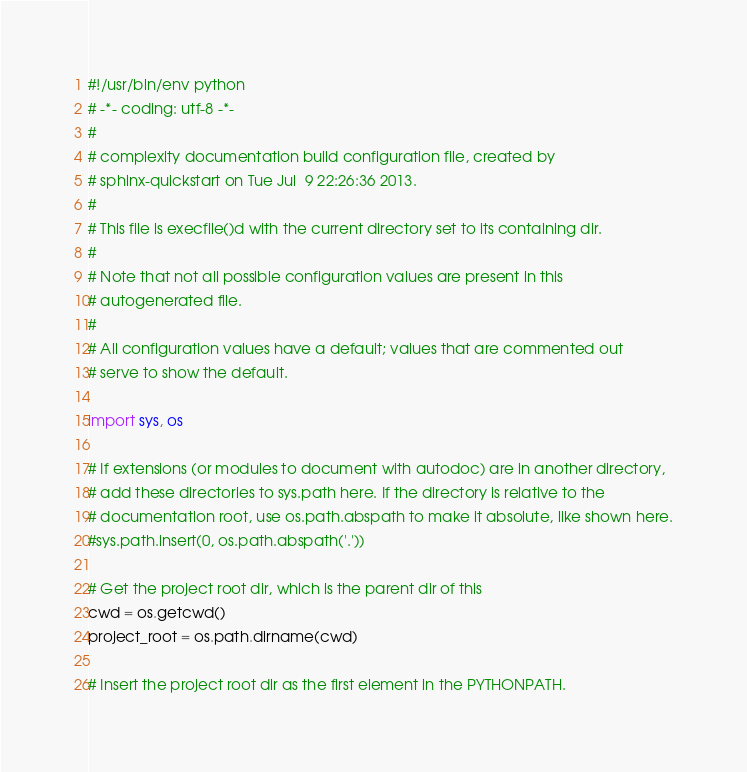Convert code to text. <code><loc_0><loc_0><loc_500><loc_500><_Python_>#!/usr/bin/env python
# -*- coding: utf-8 -*-
#
# complexity documentation build configuration file, created by
# sphinx-quickstart on Tue Jul  9 22:26:36 2013.
#
# This file is execfile()d with the current directory set to its containing dir.
#
# Note that not all possible configuration values are present in this
# autogenerated file.
#
# All configuration values have a default; values that are commented out
# serve to show the default.

import sys, os

# If extensions (or modules to document with autodoc) are in another directory,
# add these directories to sys.path here. If the directory is relative to the
# documentation root, use os.path.abspath to make it absolute, like shown here.
#sys.path.insert(0, os.path.abspath('.'))

# Get the project root dir, which is the parent dir of this
cwd = os.getcwd()
project_root = os.path.dirname(cwd)

# Insert the project root dir as the first element in the PYTHONPATH.</code> 